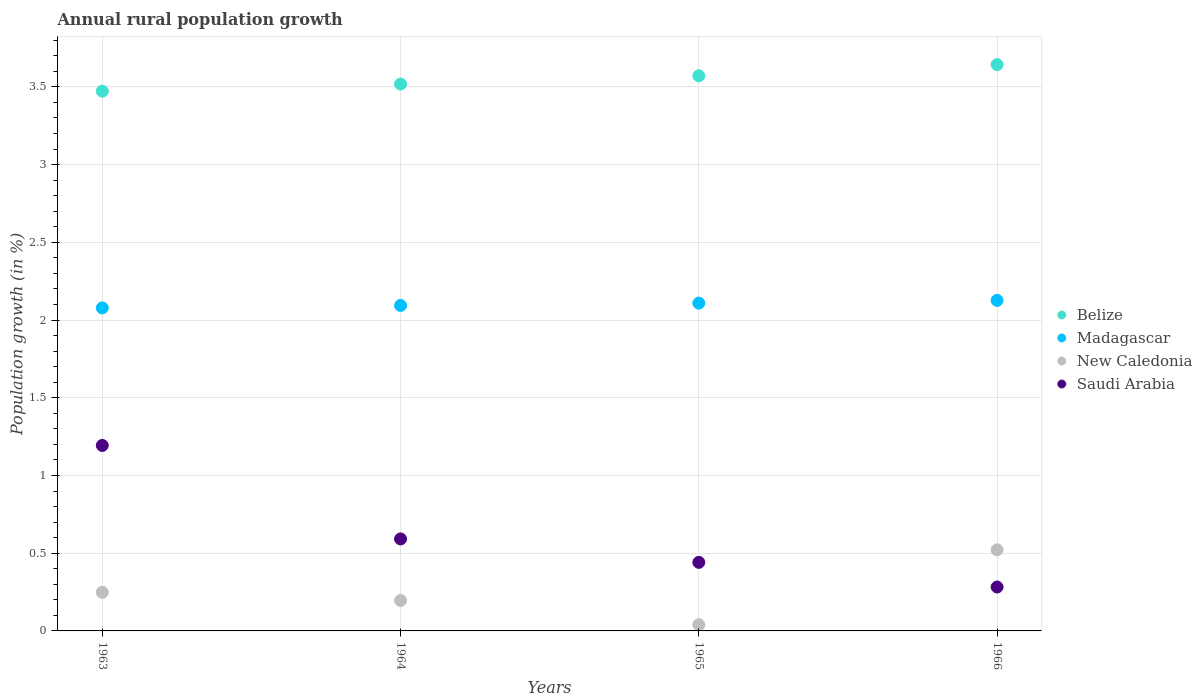What is the percentage of rural population growth in Belize in 1964?
Make the answer very short. 3.52. Across all years, what is the maximum percentage of rural population growth in New Caledonia?
Provide a short and direct response. 0.52. Across all years, what is the minimum percentage of rural population growth in New Caledonia?
Offer a terse response. 0.04. In which year was the percentage of rural population growth in Madagascar maximum?
Provide a short and direct response. 1966. In which year was the percentage of rural population growth in Madagascar minimum?
Offer a very short reply. 1963. What is the total percentage of rural population growth in Saudi Arabia in the graph?
Your response must be concise. 2.51. What is the difference between the percentage of rural population growth in Madagascar in 1964 and that in 1965?
Provide a succinct answer. -0.02. What is the difference between the percentage of rural population growth in Belize in 1966 and the percentage of rural population growth in Saudi Arabia in 1963?
Offer a very short reply. 2.45. What is the average percentage of rural population growth in Madagascar per year?
Provide a short and direct response. 2.1. In the year 1966, what is the difference between the percentage of rural population growth in New Caledonia and percentage of rural population growth in Belize?
Your answer should be compact. -3.12. What is the ratio of the percentage of rural population growth in Saudi Arabia in 1965 to that in 1966?
Offer a terse response. 1.56. Is the difference between the percentage of rural population growth in New Caledonia in 1965 and 1966 greater than the difference between the percentage of rural population growth in Belize in 1965 and 1966?
Ensure brevity in your answer.  No. What is the difference between the highest and the second highest percentage of rural population growth in Madagascar?
Your response must be concise. 0.02. What is the difference between the highest and the lowest percentage of rural population growth in Saudi Arabia?
Keep it short and to the point. 0.91. In how many years, is the percentage of rural population growth in Madagascar greater than the average percentage of rural population growth in Madagascar taken over all years?
Ensure brevity in your answer.  2. Is it the case that in every year, the sum of the percentage of rural population growth in Belize and percentage of rural population growth in Madagascar  is greater than the percentage of rural population growth in New Caledonia?
Provide a succinct answer. Yes. Is the percentage of rural population growth in Saudi Arabia strictly greater than the percentage of rural population growth in New Caledonia over the years?
Give a very brief answer. No. How many dotlines are there?
Give a very brief answer. 4. What is the difference between two consecutive major ticks on the Y-axis?
Provide a succinct answer. 0.5. Are the values on the major ticks of Y-axis written in scientific E-notation?
Offer a terse response. No. Does the graph contain any zero values?
Your response must be concise. No. Does the graph contain grids?
Your answer should be very brief. Yes. How many legend labels are there?
Provide a succinct answer. 4. How are the legend labels stacked?
Your answer should be compact. Vertical. What is the title of the graph?
Your answer should be very brief. Annual rural population growth. What is the label or title of the Y-axis?
Make the answer very short. Population growth (in %). What is the Population growth (in %) of Belize in 1963?
Your response must be concise. 3.47. What is the Population growth (in %) of Madagascar in 1963?
Keep it short and to the point. 2.08. What is the Population growth (in %) in New Caledonia in 1963?
Your answer should be very brief. 0.25. What is the Population growth (in %) of Saudi Arabia in 1963?
Give a very brief answer. 1.19. What is the Population growth (in %) in Belize in 1964?
Ensure brevity in your answer.  3.52. What is the Population growth (in %) in Madagascar in 1964?
Give a very brief answer. 2.09. What is the Population growth (in %) of New Caledonia in 1964?
Offer a very short reply. 0.2. What is the Population growth (in %) in Saudi Arabia in 1964?
Provide a succinct answer. 0.59. What is the Population growth (in %) of Belize in 1965?
Your answer should be compact. 3.57. What is the Population growth (in %) in Madagascar in 1965?
Provide a succinct answer. 2.11. What is the Population growth (in %) in New Caledonia in 1965?
Ensure brevity in your answer.  0.04. What is the Population growth (in %) of Saudi Arabia in 1965?
Make the answer very short. 0.44. What is the Population growth (in %) in Belize in 1966?
Offer a very short reply. 3.64. What is the Population growth (in %) in Madagascar in 1966?
Provide a short and direct response. 2.13. What is the Population growth (in %) in New Caledonia in 1966?
Your response must be concise. 0.52. What is the Population growth (in %) in Saudi Arabia in 1966?
Offer a terse response. 0.28. Across all years, what is the maximum Population growth (in %) of Belize?
Your response must be concise. 3.64. Across all years, what is the maximum Population growth (in %) of Madagascar?
Offer a terse response. 2.13. Across all years, what is the maximum Population growth (in %) in New Caledonia?
Give a very brief answer. 0.52. Across all years, what is the maximum Population growth (in %) in Saudi Arabia?
Keep it short and to the point. 1.19. Across all years, what is the minimum Population growth (in %) in Belize?
Give a very brief answer. 3.47. Across all years, what is the minimum Population growth (in %) in Madagascar?
Provide a short and direct response. 2.08. Across all years, what is the minimum Population growth (in %) of New Caledonia?
Provide a short and direct response. 0.04. Across all years, what is the minimum Population growth (in %) of Saudi Arabia?
Provide a short and direct response. 0.28. What is the total Population growth (in %) of Belize in the graph?
Provide a short and direct response. 14.2. What is the total Population growth (in %) in Madagascar in the graph?
Keep it short and to the point. 8.41. What is the total Population growth (in %) of New Caledonia in the graph?
Offer a terse response. 1.01. What is the total Population growth (in %) of Saudi Arabia in the graph?
Keep it short and to the point. 2.51. What is the difference between the Population growth (in %) of Belize in 1963 and that in 1964?
Your answer should be very brief. -0.05. What is the difference between the Population growth (in %) in Madagascar in 1963 and that in 1964?
Keep it short and to the point. -0.02. What is the difference between the Population growth (in %) of New Caledonia in 1963 and that in 1964?
Ensure brevity in your answer.  0.05. What is the difference between the Population growth (in %) of Saudi Arabia in 1963 and that in 1964?
Ensure brevity in your answer.  0.6. What is the difference between the Population growth (in %) in Belize in 1963 and that in 1965?
Your response must be concise. -0.1. What is the difference between the Population growth (in %) in Madagascar in 1963 and that in 1965?
Provide a succinct answer. -0.03. What is the difference between the Population growth (in %) in New Caledonia in 1963 and that in 1965?
Your answer should be compact. 0.21. What is the difference between the Population growth (in %) in Saudi Arabia in 1963 and that in 1965?
Give a very brief answer. 0.75. What is the difference between the Population growth (in %) of Belize in 1963 and that in 1966?
Provide a succinct answer. -0.17. What is the difference between the Population growth (in %) in Madagascar in 1963 and that in 1966?
Provide a short and direct response. -0.05. What is the difference between the Population growth (in %) of New Caledonia in 1963 and that in 1966?
Offer a very short reply. -0.27. What is the difference between the Population growth (in %) of Saudi Arabia in 1963 and that in 1966?
Provide a short and direct response. 0.91. What is the difference between the Population growth (in %) in Belize in 1964 and that in 1965?
Your answer should be compact. -0.05. What is the difference between the Population growth (in %) in Madagascar in 1964 and that in 1965?
Make the answer very short. -0.02. What is the difference between the Population growth (in %) of New Caledonia in 1964 and that in 1965?
Provide a succinct answer. 0.16. What is the difference between the Population growth (in %) in Saudi Arabia in 1964 and that in 1965?
Your response must be concise. 0.15. What is the difference between the Population growth (in %) of Belize in 1964 and that in 1966?
Your answer should be compact. -0.13. What is the difference between the Population growth (in %) in Madagascar in 1964 and that in 1966?
Give a very brief answer. -0.03. What is the difference between the Population growth (in %) in New Caledonia in 1964 and that in 1966?
Your answer should be very brief. -0.33. What is the difference between the Population growth (in %) in Saudi Arabia in 1964 and that in 1966?
Provide a short and direct response. 0.31. What is the difference between the Population growth (in %) in Belize in 1965 and that in 1966?
Provide a succinct answer. -0.07. What is the difference between the Population growth (in %) in Madagascar in 1965 and that in 1966?
Your answer should be very brief. -0.02. What is the difference between the Population growth (in %) of New Caledonia in 1965 and that in 1966?
Your answer should be compact. -0.48. What is the difference between the Population growth (in %) of Saudi Arabia in 1965 and that in 1966?
Your response must be concise. 0.16. What is the difference between the Population growth (in %) of Belize in 1963 and the Population growth (in %) of Madagascar in 1964?
Give a very brief answer. 1.38. What is the difference between the Population growth (in %) in Belize in 1963 and the Population growth (in %) in New Caledonia in 1964?
Offer a very short reply. 3.28. What is the difference between the Population growth (in %) of Belize in 1963 and the Population growth (in %) of Saudi Arabia in 1964?
Your answer should be compact. 2.88. What is the difference between the Population growth (in %) of Madagascar in 1963 and the Population growth (in %) of New Caledonia in 1964?
Make the answer very short. 1.88. What is the difference between the Population growth (in %) in Madagascar in 1963 and the Population growth (in %) in Saudi Arabia in 1964?
Your answer should be very brief. 1.49. What is the difference between the Population growth (in %) in New Caledonia in 1963 and the Population growth (in %) in Saudi Arabia in 1964?
Give a very brief answer. -0.34. What is the difference between the Population growth (in %) of Belize in 1963 and the Population growth (in %) of Madagascar in 1965?
Your answer should be compact. 1.36. What is the difference between the Population growth (in %) of Belize in 1963 and the Population growth (in %) of New Caledonia in 1965?
Keep it short and to the point. 3.43. What is the difference between the Population growth (in %) of Belize in 1963 and the Population growth (in %) of Saudi Arabia in 1965?
Your answer should be compact. 3.03. What is the difference between the Population growth (in %) of Madagascar in 1963 and the Population growth (in %) of New Caledonia in 1965?
Your answer should be compact. 2.04. What is the difference between the Population growth (in %) of Madagascar in 1963 and the Population growth (in %) of Saudi Arabia in 1965?
Provide a succinct answer. 1.64. What is the difference between the Population growth (in %) in New Caledonia in 1963 and the Population growth (in %) in Saudi Arabia in 1965?
Keep it short and to the point. -0.19. What is the difference between the Population growth (in %) of Belize in 1963 and the Population growth (in %) of Madagascar in 1966?
Offer a very short reply. 1.35. What is the difference between the Population growth (in %) in Belize in 1963 and the Population growth (in %) in New Caledonia in 1966?
Keep it short and to the point. 2.95. What is the difference between the Population growth (in %) in Belize in 1963 and the Population growth (in %) in Saudi Arabia in 1966?
Your answer should be compact. 3.19. What is the difference between the Population growth (in %) of Madagascar in 1963 and the Population growth (in %) of New Caledonia in 1966?
Provide a short and direct response. 1.56. What is the difference between the Population growth (in %) of Madagascar in 1963 and the Population growth (in %) of Saudi Arabia in 1966?
Give a very brief answer. 1.8. What is the difference between the Population growth (in %) in New Caledonia in 1963 and the Population growth (in %) in Saudi Arabia in 1966?
Keep it short and to the point. -0.03. What is the difference between the Population growth (in %) of Belize in 1964 and the Population growth (in %) of Madagascar in 1965?
Provide a succinct answer. 1.41. What is the difference between the Population growth (in %) of Belize in 1964 and the Population growth (in %) of New Caledonia in 1965?
Your response must be concise. 3.48. What is the difference between the Population growth (in %) of Belize in 1964 and the Population growth (in %) of Saudi Arabia in 1965?
Give a very brief answer. 3.08. What is the difference between the Population growth (in %) of Madagascar in 1964 and the Population growth (in %) of New Caledonia in 1965?
Your answer should be very brief. 2.05. What is the difference between the Population growth (in %) in Madagascar in 1964 and the Population growth (in %) in Saudi Arabia in 1965?
Give a very brief answer. 1.65. What is the difference between the Population growth (in %) of New Caledonia in 1964 and the Population growth (in %) of Saudi Arabia in 1965?
Provide a short and direct response. -0.25. What is the difference between the Population growth (in %) in Belize in 1964 and the Population growth (in %) in Madagascar in 1966?
Your response must be concise. 1.39. What is the difference between the Population growth (in %) in Belize in 1964 and the Population growth (in %) in New Caledonia in 1966?
Your response must be concise. 3. What is the difference between the Population growth (in %) of Belize in 1964 and the Population growth (in %) of Saudi Arabia in 1966?
Your response must be concise. 3.24. What is the difference between the Population growth (in %) in Madagascar in 1964 and the Population growth (in %) in New Caledonia in 1966?
Ensure brevity in your answer.  1.57. What is the difference between the Population growth (in %) of Madagascar in 1964 and the Population growth (in %) of Saudi Arabia in 1966?
Offer a terse response. 1.81. What is the difference between the Population growth (in %) in New Caledonia in 1964 and the Population growth (in %) in Saudi Arabia in 1966?
Your response must be concise. -0.09. What is the difference between the Population growth (in %) in Belize in 1965 and the Population growth (in %) in Madagascar in 1966?
Offer a very short reply. 1.44. What is the difference between the Population growth (in %) in Belize in 1965 and the Population growth (in %) in New Caledonia in 1966?
Make the answer very short. 3.05. What is the difference between the Population growth (in %) of Belize in 1965 and the Population growth (in %) of Saudi Arabia in 1966?
Provide a succinct answer. 3.29. What is the difference between the Population growth (in %) of Madagascar in 1965 and the Population growth (in %) of New Caledonia in 1966?
Provide a short and direct response. 1.59. What is the difference between the Population growth (in %) of Madagascar in 1965 and the Population growth (in %) of Saudi Arabia in 1966?
Your answer should be very brief. 1.83. What is the difference between the Population growth (in %) in New Caledonia in 1965 and the Population growth (in %) in Saudi Arabia in 1966?
Keep it short and to the point. -0.24. What is the average Population growth (in %) of Belize per year?
Your response must be concise. 3.55. What is the average Population growth (in %) in Madagascar per year?
Offer a very short reply. 2.1. What is the average Population growth (in %) in New Caledonia per year?
Your answer should be very brief. 0.25. What is the average Population growth (in %) in Saudi Arabia per year?
Offer a terse response. 0.63. In the year 1963, what is the difference between the Population growth (in %) of Belize and Population growth (in %) of Madagascar?
Your response must be concise. 1.39. In the year 1963, what is the difference between the Population growth (in %) in Belize and Population growth (in %) in New Caledonia?
Offer a very short reply. 3.22. In the year 1963, what is the difference between the Population growth (in %) of Belize and Population growth (in %) of Saudi Arabia?
Provide a short and direct response. 2.28. In the year 1963, what is the difference between the Population growth (in %) of Madagascar and Population growth (in %) of New Caledonia?
Provide a short and direct response. 1.83. In the year 1963, what is the difference between the Population growth (in %) in Madagascar and Population growth (in %) in Saudi Arabia?
Provide a succinct answer. 0.88. In the year 1963, what is the difference between the Population growth (in %) in New Caledonia and Population growth (in %) in Saudi Arabia?
Make the answer very short. -0.94. In the year 1964, what is the difference between the Population growth (in %) in Belize and Population growth (in %) in Madagascar?
Your answer should be very brief. 1.42. In the year 1964, what is the difference between the Population growth (in %) of Belize and Population growth (in %) of New Caledonia?
Offer a terse response. 3.32. In the year 1964, what is the difference between the Population growth (in %) in Belize and Population growth (in %) in Saudi Arabia?
Offer a very short reply. 2.93. In the year 1964, what is the difference between the Population growth (in %) of Madagascar and Population growth (in %) of New Caledonia?
Provide a short and direct response. 1.9. In the year 1964, what is the difference between the Population growth (in %) of Madagascar and Population growth (in %) of Saudi Arabia?
Your answer should be compact. 1.5. In the year 1964, what is the difference between the Population growth (in %) of New Caledonia and Population growth (in %) of Saudi Arabia?
Your answer should be very brief. -0.4. In the year 1965, what is the difference between the Population growth (in %) in Belize and Population growth (in %) in Madagascar?
Keep it short and to the point. 1.46. In the year 1965, what is the difference between the Population growth (in %) in Belize and Population growth (in %) in New Caledonia?
Your answer should be very brief. 3.53. In the year 1965, what is the difference between the Population growth (in %) in Belize and Population growth (in %) in Saudi Arabia?
Your answer should be compact. 3.13. In the year 1965, what is the difference between the Population growth (in %) in Madagascar and Population growth (in %) in New Caledonia?
Provide a succinct answer. 2.07. In the year 1965, what is the difference between the Population growth (in %) of Madagascar and Population growth (in %) of Saudi Arabia?
Make the answer very short. 1.67. In the year 1965, what is the difference between the Population growth (in %) in New Caledonia and Population growth (in %) in Saudi Arabia?
Offer a very short reply. -0.4. In the year 1966, what is the difference between the Population growth (in %) in Belize and Population growth (in %) in Madagascar?
Make the answer very short. 1.52. In the year 1966, what is the difference between the Population growth (in %) of Belize and Population growth (in %) of New Caledonia?
Keep it short and to the point. 3.12. In the year 1966, what is the difference between the Population growth (in %) in Belize and Population growth (in %) in Saudi Arabia?
Your answer should be compact. 3.36. In the year 1966, what is the difference between the Population growth (in %) in Madagascar and Population growth (in %) in New Caledonia?
Make the answer very short. 1.6. In the year 1966, what is the difference between the Population growth (in %) in Madagascar and Population growth (in %) in Saudi Arabia?
Give a very brief answer. 1.84. In the year 1966, what is the difference between the Population growth (in %) of New Caledonia and Population growth (in %) of Saudi Arabia?
Offer a terse response. 0.24. What is the ratio of the Population growth (in %) of Belize in 1963 to that in 1964?
Your response must be concise. 0.99. What is the ratio of the Population growth (in %) in New Caledonia in 1963 to that in 1964?
Ensure brevity in your answer.  1.27. What is the ratio of the Population growth (in %) of Saudi Arabia in 1963 to that in 1964?
Ensure brevity in your answer.  2.02. What is the ratio of the Population growth (in %) of Belize in 1963 to that in 1965?
Offer a terse response. 0.97. What is the ratio of the Population growth (in %) in Madagascar in 1963 to that in 1965?
Offer a terse response. 0.99. What is the ratio of the Population growth (in %) in New Caledonia in 1963 to that in 1965?
Keep it short and to the point. 6.22. What is the ratio of the Population growth (in %) of Saudi Arabia in 1963 to that in 1965?
Your answer should be very brief. 2.71. What is the ratio of the Population growth (in %) of Belize in 1963 to that in 1966?
Your answer should be very brief. 0.95. What is the ratio of the Population growth (in %) of Madagascar in 1963 to that in 1966?
Your answer should be very brief. 0.98. What is the ratio of the Population growth (in %) of New Caledonia in 1963 to that in 1966?
Offer a terse response. 0.48. What is the ratio of the Population growth (in %) in Saudi Arabia in 1963 to that in 1966?
Provide a short and direct response. 4.23. What is the ratio of the Population growth (in %) of Belize in 1964 to that in 1965?
Make the answer very short. 0.99. What is the ratio of the Population growth (in %) of New Caledonia in 1964 to that in 1965?
Your answer should be very brief. 4.91. What is the ratio of the Population growth (in %) of Saudi Arabia in 1964 to that in 1965?
Offer a very short reply. 1.34. What is the ratio of the Population growth (in %) of Belize in 1964 to that in 1966?
Give a very brief answer. 0.97. What is the ratio of the Population growth (in %) of Madagascar in 1964 to that in 1966?
Your answer should be very brief. 0.98. What is the ratio of the Population growth (in %) in New Caledonia in 1964 to that in 1966?
Keep it short and to the point. 0.38. What is the ratio of the Population growth (in %) in Saudi Arabia in 1964 to that in 1966?
Your answer should be very brief. 2.1. What is the ratio of the Population growth (in %) of Belize in 1965 to that in 1966?
Offer a very short reply. 0.98. What is the ratio of the Population growth (in %) in Madagascar in 1965 to that in 1966?
Give a very brief answer. 0.99. What is the ratio of the Population growth (in %) in New Caledonia in 1965 to that in 1966?
Give a very brief answer. 0.08. What is the ratio of the Population growth (in %) in Saudi Arabia in 1965 to that in 1966?
Provide a short and direct response. 1.56. What is the difference between the highest and the second highest Population growth (in %) in Belize?
Make the answer very short. 0.07. What is the difference between the highest and the second highest Population growth (in %) in Madagascar?
Offer a terse response. 0.02. What is the difference between the highest and the second highest Population growth (in %) of New Caledonia?
Provide a short and direct response. 0.27. What is the difference between the highest and the second highest Population growth (in %) of Saudi Arabia?
Provide a short and direct response. 0.6. What is the difference between the highest and the lowest Population growth (in %) in Belize?
Provide a short and direct response. 0.17. What is the difference between the highest and the lowest Population growth (in %) in Madagascar?
Your answer should be compact. 0.05. What is the difference between the highest and the lowest Population growth (in %) of New Caledonia?
Keep it short and to the point. 0.48. What is the difference between the highest and the lowest Population growth (in %) in Saudi Arabia?
Your response must be concise. 0.91. 